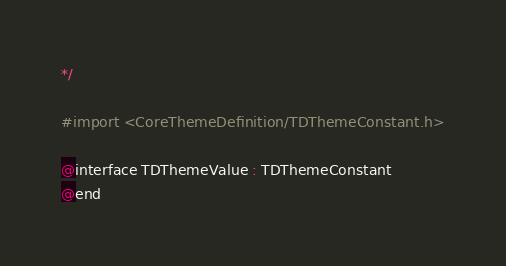Convert code to text. <code><loc_0><loc_0><loc_500><loc_500><_C_>*/

#import <CoreThemeDefinition/TDThemeConstant.h>

@interface TDThemeValue : TDThemeConstant
@end

</code> 